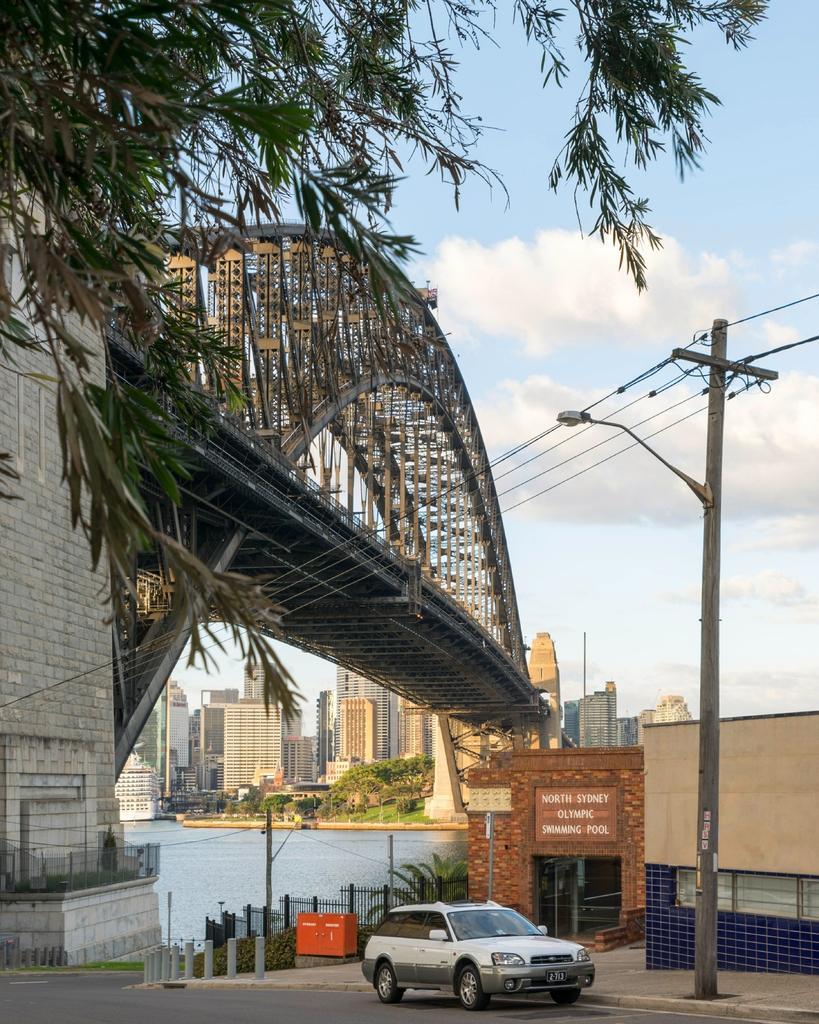Can you describe this image briefly? In the foreground of the image we can see a road, car and water body. In the middle of the image we can see the bridge, current pole and wires. On the top of the image we can see the sky and leaves. 